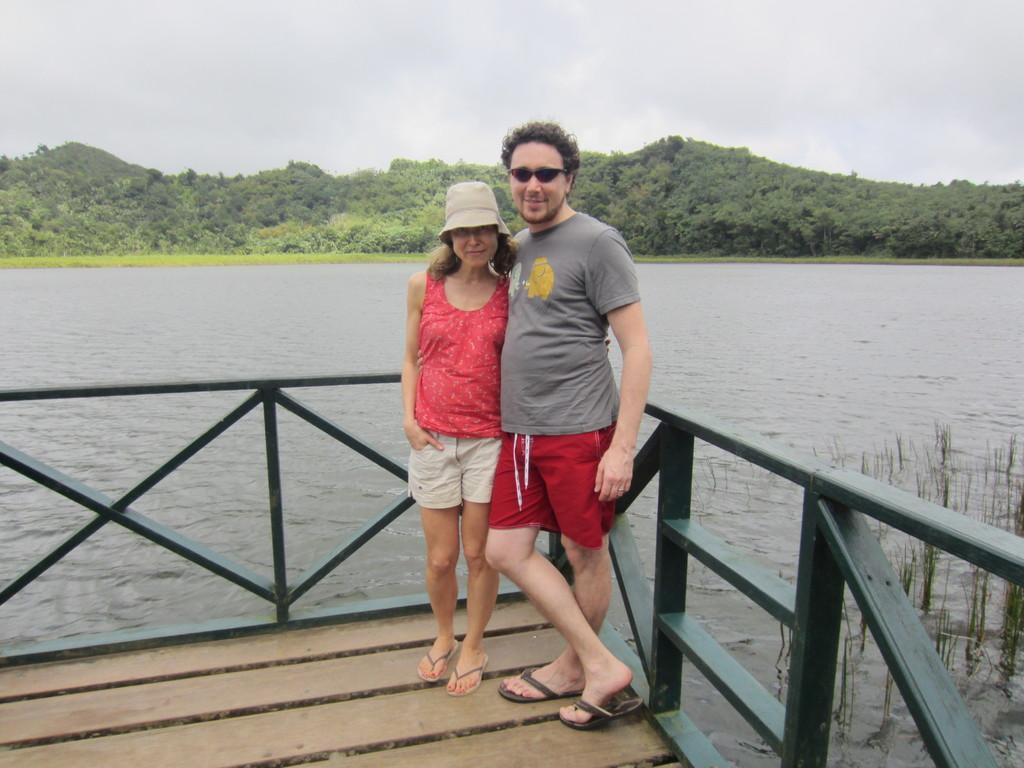Describe this image in one or two sentences. In this image we can see a male person wearing black color T-shirt, red color short, black color shades and female person wearing red color top, white color short and cap standing on wooden floor and leaning to the fencing and in the background of the image there is some water, there are some trees and top of the image there is cloudy sky. 